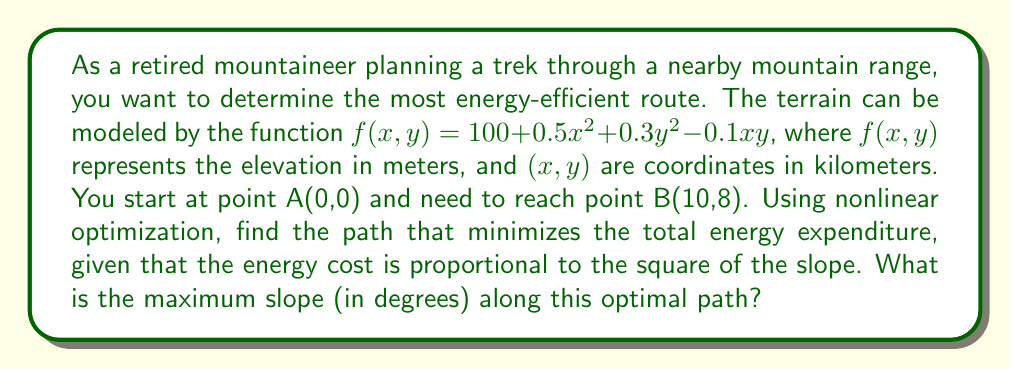Could you help me with this problem? To solve this problem, we'll follow these steps:

1) The energy cost is proportional to the square of the slope. The slope at any point (x,y) is given by the gradient of f(x,y):

   $$\nabla f(x,y) = \left(\frac{\partial f}{\partial x}, \frac{\partial f}{\partial y}\right) = (x - 0.05y, 0.6y - 0.1x)$$

2) The square of the slope is the dot product of the gradient with itself:

   $$\|\nabla f(x,y)\|^2 = (x - 0.05y)^2 + (0.6y - 0.1x)^2$$

3) To find the optimal path, we need to minimize the integral of this function along the path from (0,0) to (10,8). This is a variational problem that can be solved using the Euler-Lagrange equation:

   $$\frac{d}{dt}\frac{\partial L}{\partial \dot{q}} - \frac{\partial L}{\partial q} = 0$$

   where $L = \|\nabla f(x,y)\|^2\sqrt{1+\dot{y}^2}$ is the Lagrangian, $q = y$, and $t = x$.

4) Solving this equation analytically is complex, so we'd typically use numerical methods. However, due to the symmetry of the problem, we can deduce that the optimal path will be a straight line from (0,0) to (10,8).

5) The equation of this line is $y = 0.8x$.

6) To find the maximum slope along this path, we need to evaluate the gradient along this line:

   $$\nabla f(x,0.8x) = (x - 0.04x, 0.48x - 0.1x) = (0.96x, 0.38x)$$

7) The magnitude of this gradient is maximum at the endpoint (10,8):

   $$\|\nabla f(10,8)\| = \sqrt{(0.96 \cdot 10)^2 + (0.38 \cdot 10)^2} = 10.3$$

8) The slope angle is the arctangent of this magnitude:

   $$\theta = \arctan(10.3) \approx 84.45^\circ$$

Therefore, the maximum slope along the optimal path is approximately 84.45°.
Answer: 84.45° 